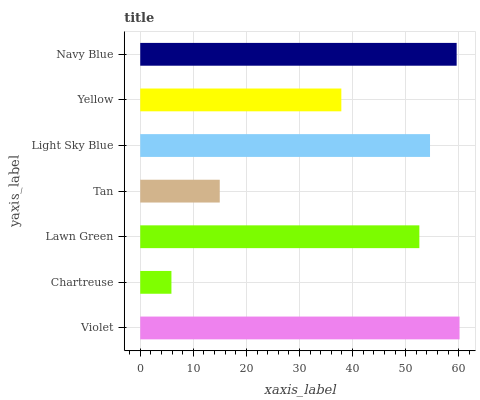Is Chartreuse the minimum?
Answer yes or no. Yes. Is Violet the maximum?
Answer yes or no. Yes. Is Lawn Green the minimum?
Answer yes or no. No. Is Lawn Green the maximum?
Answer yes or no. No. Is Lawn Green greater than Chartreuse?
Answer yes or no. Yes. Is Chartreuse less than Lawn Green?
Answer yes or no. Yes. Is Chartreuse greater than Lawn Green?
Answer yes or no. No. Is Lawn Green less than Chartreuse?
Answer yes or no. No. Is Lawn Green the high median?
Answer yes or no. Yes. Is Lawn Green the low median?
Answer yes or no. Yes. Is Light Sky Blue the high median?
Answer yes or no. No. Is Light Sky Blue the low median?
Answer yes or no. No. 